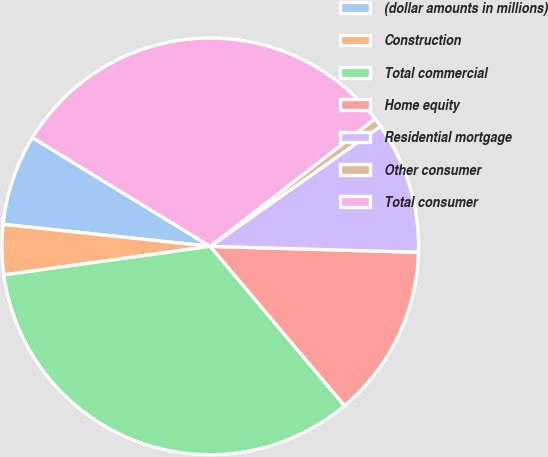Convert chart to OTSL. <chart><loc_0><loc_0><loc_500><loc_500><pie_chart><fcel>(dollar amounts in millions)<fcel>Construction<fcel>Total commercial<fcel>Home equity<fcel>Residential mortgage<fcel>Other consumer<fcel>Total consumer<nl><fcel>7.05%<fcel>3.88%<fcel>33.96%<fcel>13.4%<fcel>10.23%<fcel>0.71%<fcel>30.78%<nl></chart> 